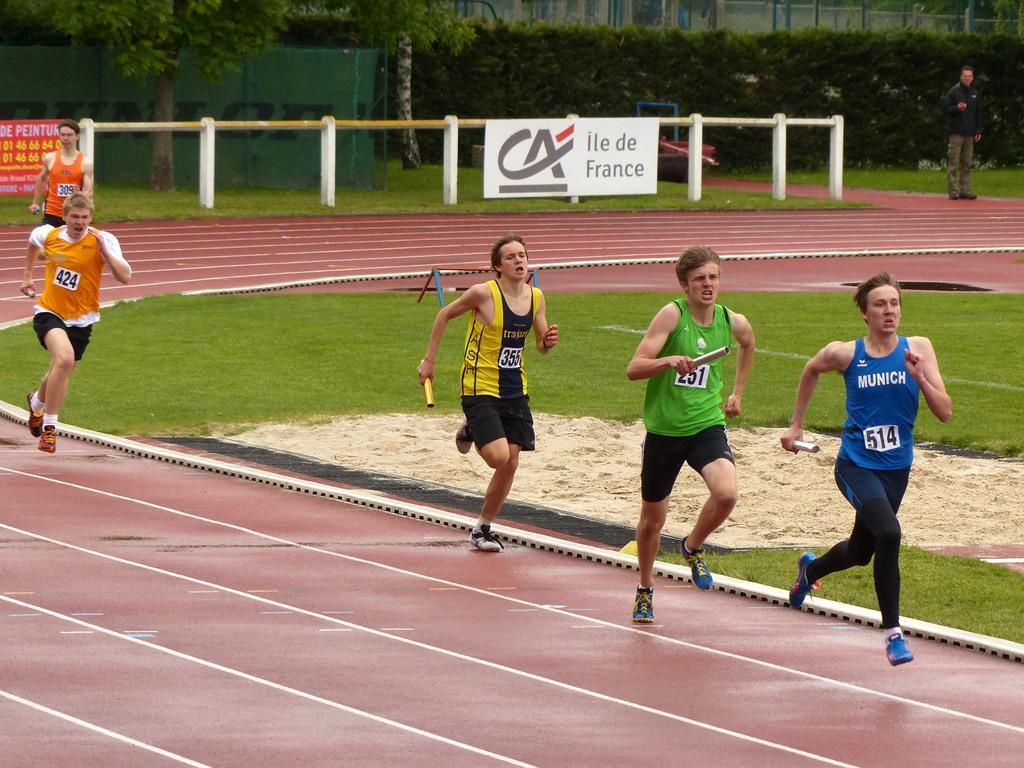How would you summarize this image in a sentence or two? In this image we can see a group of people standing on the ground holding some poles. We can also see some grass, the fence, boards with some text on it, some plants and trees. At the top right we can see a person standing. 